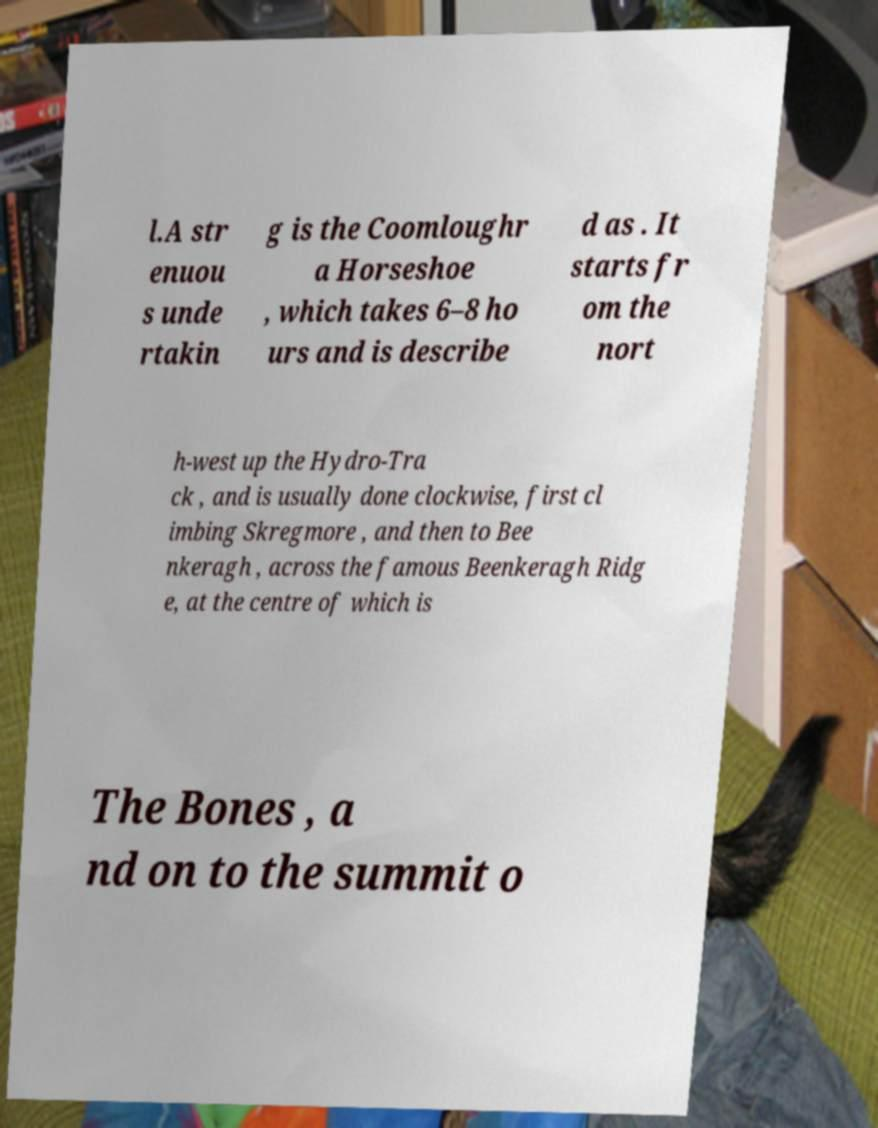Please identify and transcribe the text found in this image. l.A str enuou s unde rtakin g is the Coomloughr a Horseshoe , which takes 6–8 ho urs and is describe d as . It starts fr om the nort h-west up the Hydro-Tra ck , and is usually done clockwise, first cl imbing Skregmore , and then to Bee nkeragh , across the famous Beenkeragh Ridg e, at the centre of which is The Bones , a nd on to the summit o 